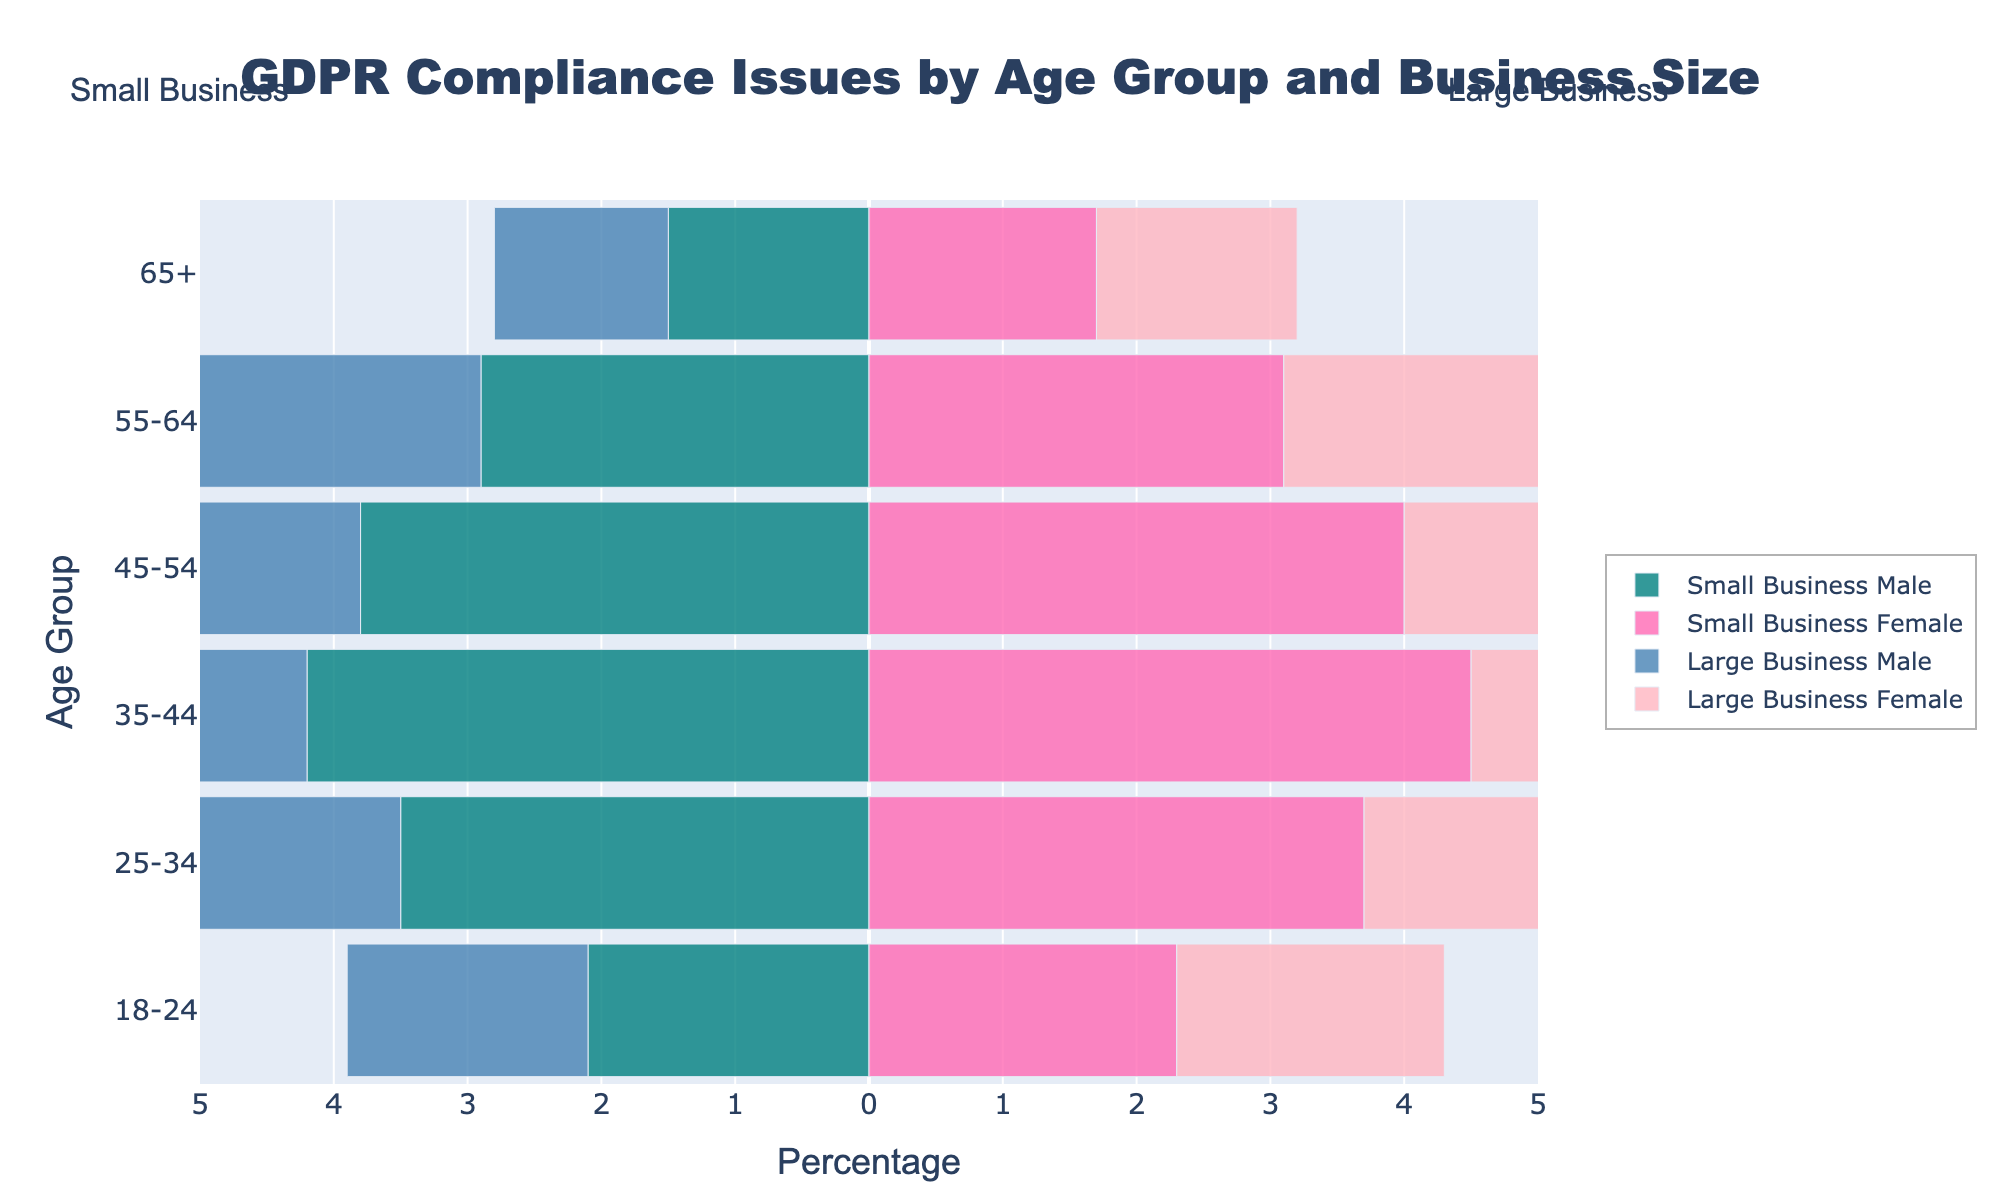How many age groups are displayed in the figure? The figure shows age groups on the y-axis. Counting them from top to bottom, there are six distinct age groups.
Answer: 6 What is the title of the figure? The title is prominently displayed at the top of the figure and reads "GDPR Compliance Issues by Age Group and Business Size".
Answer: GDPR Compliance Issues by Age Group and Business Size Which gender has the higher percentage of GDPR compliance issues in small businesses for the 35-44 age group? Comparing the bars for "Small Business Male" and "Small Business Female" in the 35-44 age group, the female bar is longer.
Answer: Female What is the percentage difference between males in small and large businesses in the 25-34 age group? The percentages for males in the 25-34 age group are 3.5% for small businesses and 3.2% for large businesses. The difference is 3.5% - 3.2% = 0.3%.
Answer: 0.3% Which age group is most affected by GDPR compliance issues in large businesses? In large businesses, look for the longest bar among the age groups. The 35-44 age group has the longest bars for both genders.
Answer: 35-44 For the 45-54 age group, which business size has higher GDPR compliance issues for females? In the 45-54 age group, compare the lengths of the bars for "Small Business Female" and "Large Business Female". The bar for small businesses is slightly longer.
Answer: Small Business What is the combined percentage of GDPR compliance issues in small businesses for the 18-24 age group? In small businesses, the percentages for males and females in the 18-24 age group are 2.1% and 2.3%, respectively. Their sum is 2.1% + 2.3% = 4.4%.
Answer: 4.4% Is there an age group in which males in large businesses have a higher percentage of GDPR compliance issues than males in small businesses? For each age group, compare the bars for "Large Business Male" versus "Small Business Male". In all age groups, "Small Business Male" has higher percentages than "Large Business Male".
Answer: No 